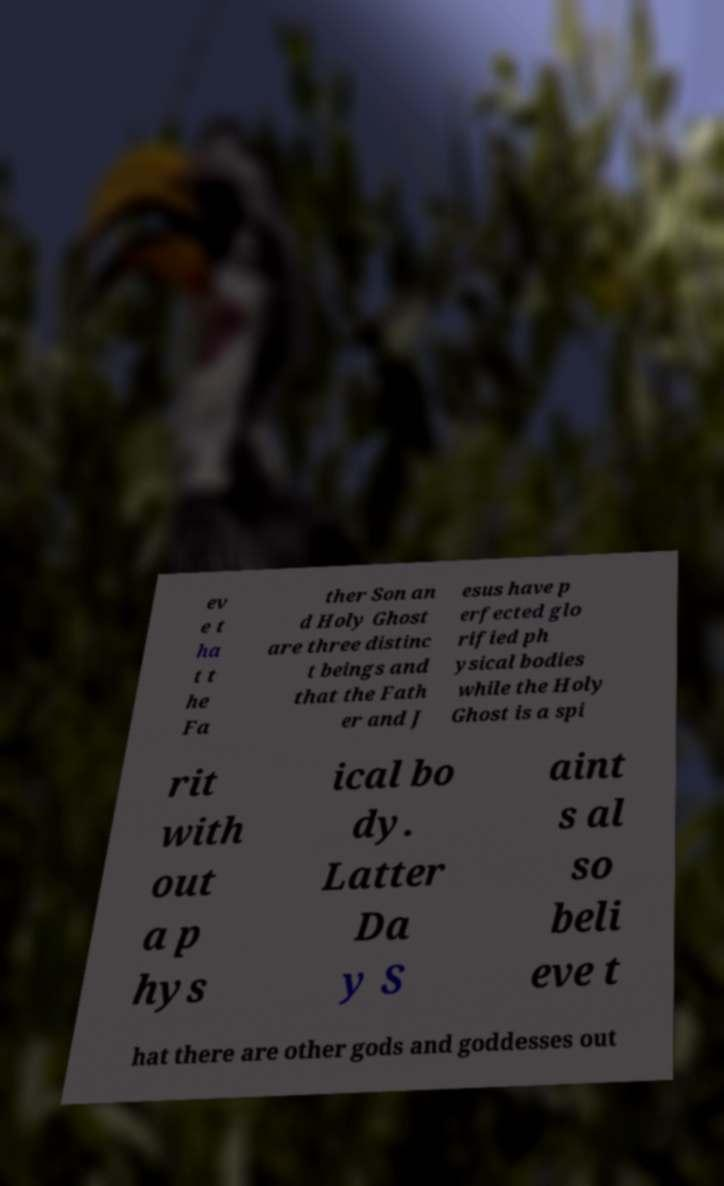There's text embedded in this image that I need extracted. Can you transcribe it verbatim? ev e t ha t t he Fa ther Son an d Holy Ghost are three distinc t beings and that the Fath er and J esus have p erfected glo rified ph ysical bodies while the Holy Ghost is a spi rit with out a p hys ical bo dy. Latter Da y S aint s al so beli eve t hat there are other gods and goddesses out 